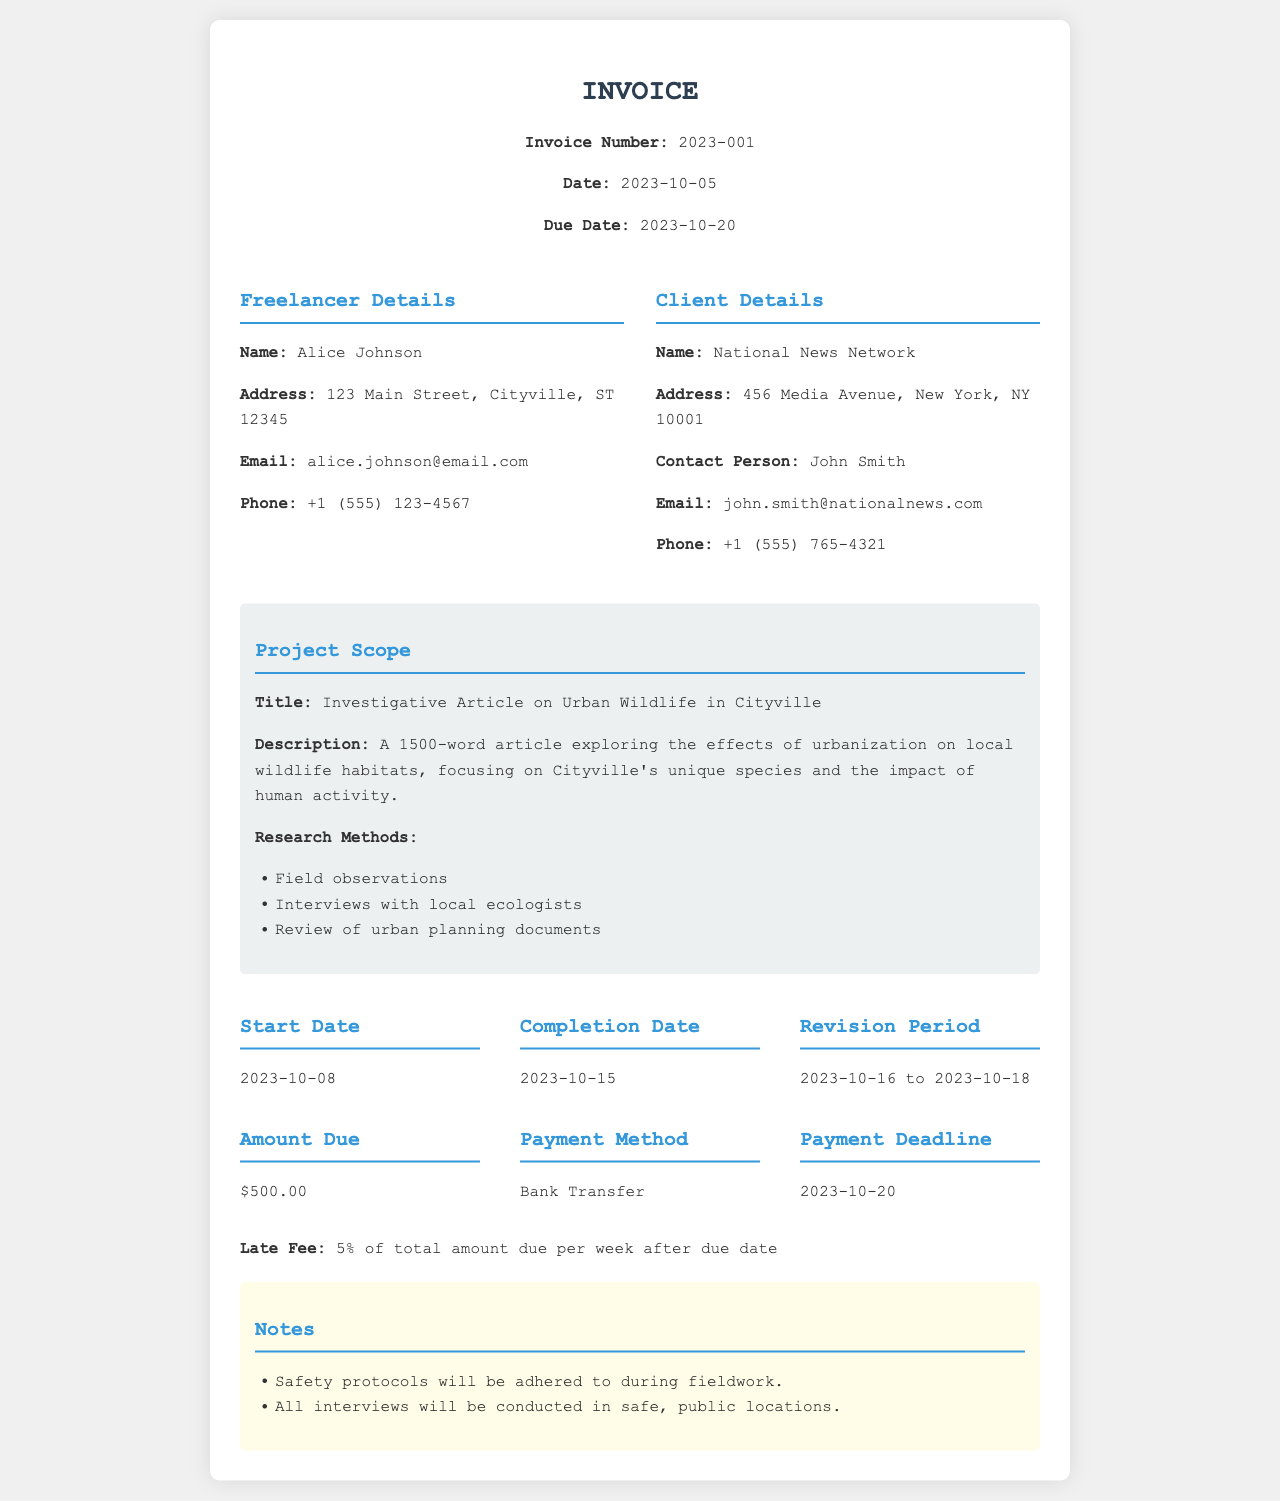what is the invoice number? The invoice number is a unique identifier for the invoice, specified in the document.
Answer: 2023-001 what is the freelancer's name? The freelancer's name is provided in the freelancer details section of the invoice.
Answer: Alice Johnson what is the due date for payment? The due date is mentioned clearly within the header section of the invoice.
Answer: 2023-10-20 what is the total amount due? The total amount due is outlined in the payment terms section of the invoice.
Answer: $500.00 what is the title of the article? The title is stated under the project scope section of the invoice.
Answer: Investigative Article on Urban Wildlife in Cityville what is the start date of the project? The start date is specified in the timeline section of the invoice.
Answer: 2023-10-08 what are the research methods mentioned? The research methods are listed in the project scope section and involve multiple techniques.
Answer: Field observations, Interviews with local ecologists, Review of urban planning documents what is the payment method specified? The payment method is elaborated in the payment terms section, indicating how payment should be made.
Answer: Bank Transfer what is the revision period? The revision period is defined in the timeline section and indicates the time allotted for revisions on the article.
Answer: 2023-10-16 to 2023-10-18 what late fee is mentioned? The late fee is specified in the terms as a financial consequence of overdue payments.
Answer: 5% of total amount due per week after due date 